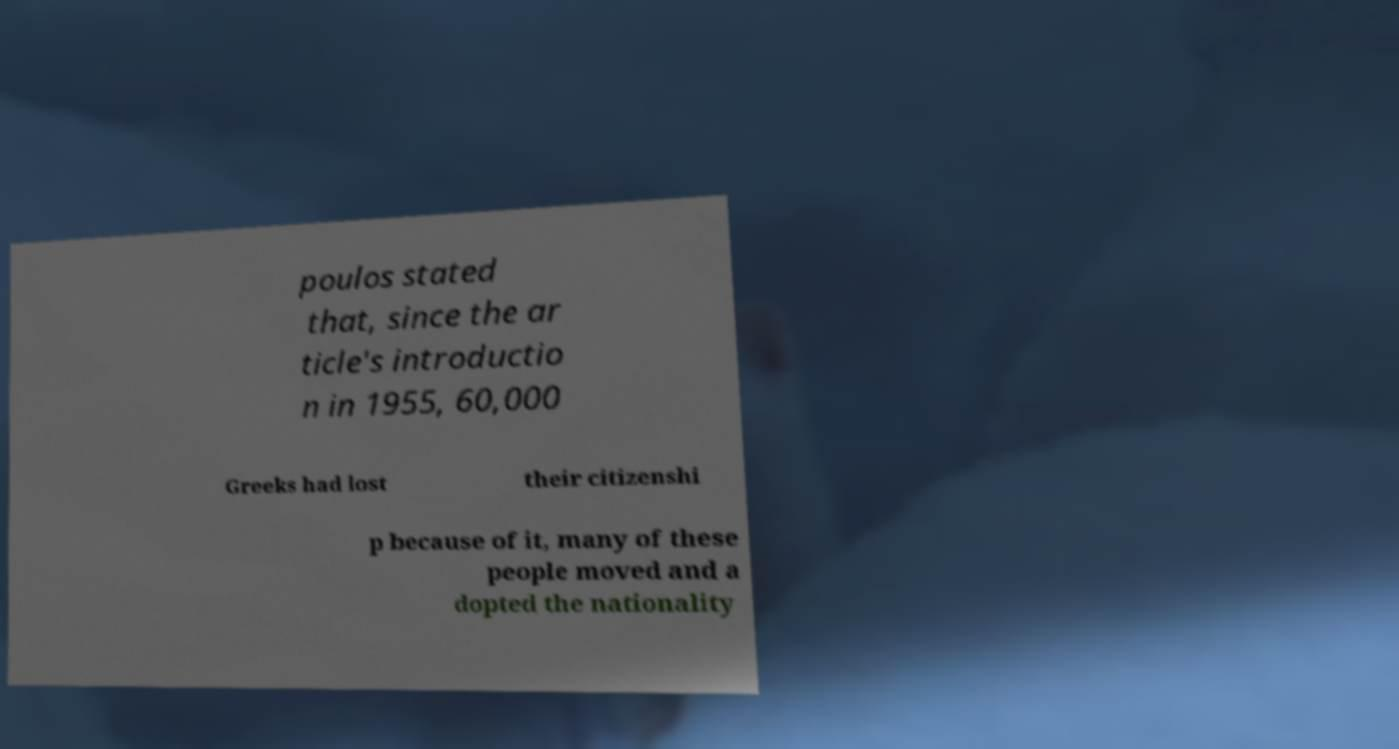I need the written content from this picture converted into text. Can you do that? poulos stated that, since the ar ticle's introductio n in 1955, 60,000 Greeks had lost their citizenshi p because of it, many of these people moved and a dopted the nationality 